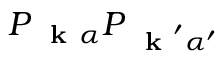<formula> <loc_0><loc_0><loc_500><loc_500>P _ { k \alpha } P _ { k ^ { \prime } \alpha ^ { \prime } }</formula> 